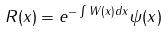Convert formula to latex. <formula><loc_0><loc_0><loc_500><loc_500>R ( x ) = e ^ { - \int W ( x ) d x } \psi ( x )</formula> 